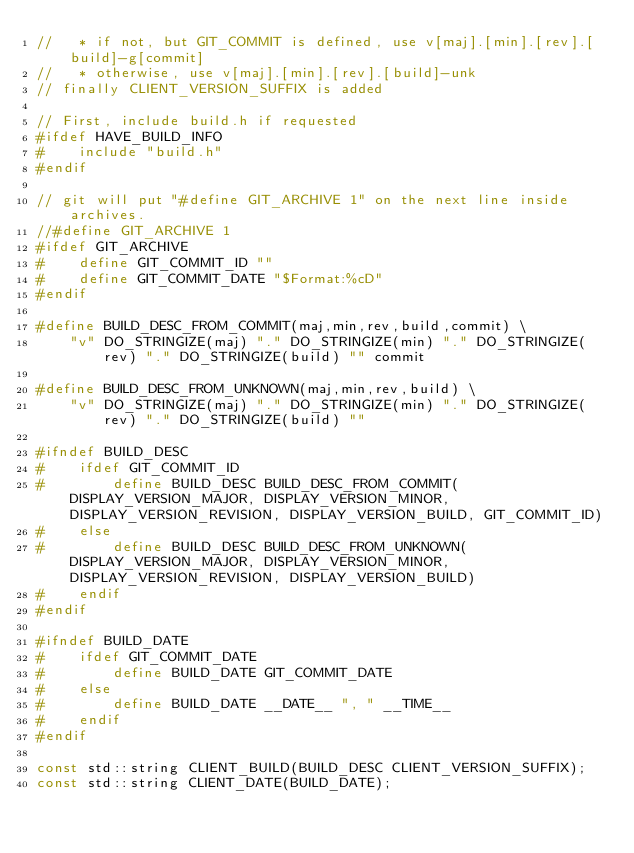<code> <loc_0><loc_0><loc_500><loc_500><_C++_>//   * if not, but GIT_COMMIT is defined, use v[maj].[min].[rev].[build]-g[commit]
//   * otherwise, use v[maj].[min].[rev].[build]-unk
// finally CLIENT_VERSION_SUFFIX is added

// First, include build.h if requested
#ifdef HAVE_BUILD_INFO
#    include "build.h"
#endif

// git will put "#define GIT_ARCHIVE 1" on the next line inside archives. 
//#define GIT_ARCHIVE 1
#ifdef GIT_ARCHIVE
#    define GIT_COMMIT_ID ""
#    define GIT_COMMIT_DATE "$Format:%cD"
#endif

#define BUILD_DESC_FROM_COMMIT(maj,min,rev,build,commit) \
    "v" DO_STRINGIZE(maj) "." DO_STRINGIZE(min) "." DO_STRINGIZE(rev) "." DO_STRINGIZE(build) "" commit

#define BUILD_DESC_FROM_UNKNOWN(maj,min,rev,build) \
    "v" DO_STRINGIZE(maj) "." DO_STRINGIZE(min) "." DO_STRINGIZE(rev) "." DO_STRINGIZE(build) ""

#ifndef BUILD_DESC
#    ifdef GIT_COMMIT_ID
#        define BUILD_DESC BUILD_DESC_FROM_COMMIT(DISPLAY_VERSION_MAJOR, DISPLAY_VERSION_MINOR, DISPLAY_VERSION_REVISION, DISPLAY_VERSION_BUILD, GIT_COMMIT_ID)
#    else
#        define BUILD_DESC BUILD_DESC_FROM_UNKNOWN(DISPLAY_VERSION_MAJOR, DISPLAY_VERSION_MINOR, DISPLAY_VERSION_REVISION, DISPLAY_VERSION_BUILD)
#    endif
#endif

#ifndef BUILD_DATE
#    ifdef GIT_COMMIT_DATE
#        define BUILD_DATE GIT_COMMIT_DATE
#    else
#        define BUILD_DATE __DATE__ ", " __TIME__
#    endif
#endif

const std::string CLIENT_BUILD(BUILD_DESC CLIENT_VERSION_SUFFIX);
const std::string CLIENT_DATE(BUILD_DATE);
</code> 